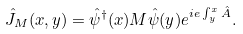Convert formula to latex. <formula><loc_0><loc_0><loc_500><loc_500>\hat { J } _ { M } ( x , y ) = \hat { \psi } ^ { \dagger } ( x ) M \hat { \psi } ( y ) e ^ { i e \int ^ { x } _ { y } \hat { A } } .</formula> 